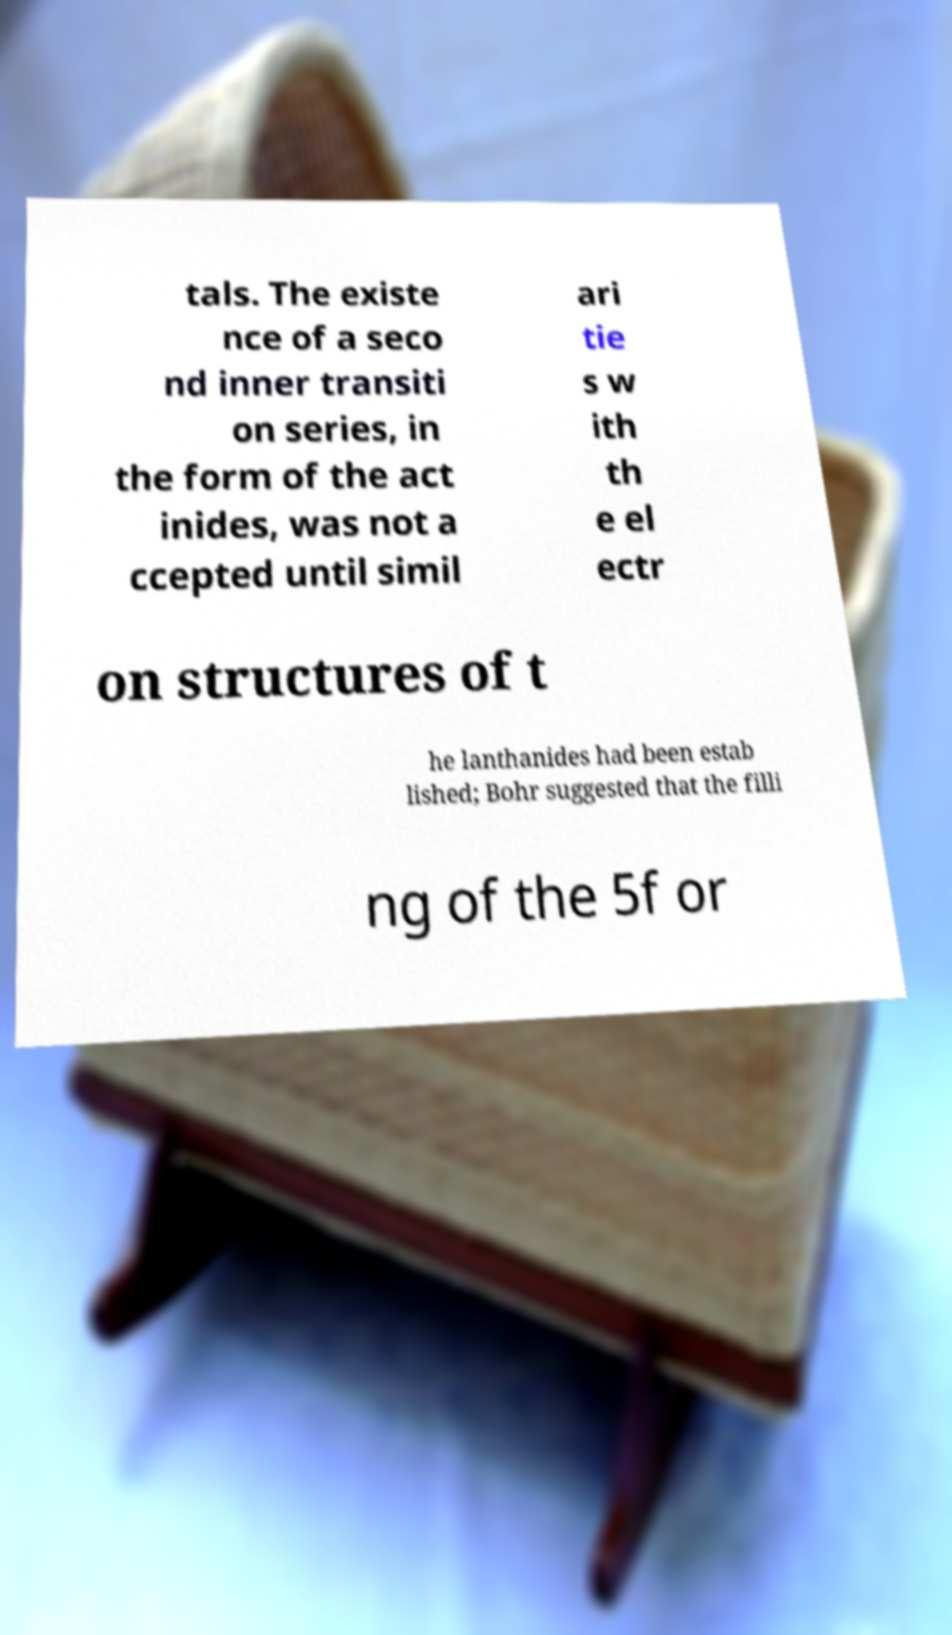What messages or text are displayed in this image? I need them in a readable, typed format. tals. The existe nce of a seco nd inner transiti on series, in the form of the act inides, was not a ccepted until simil ari tie s w ith th e el ectr on structures of t he lanthanides had been estab lished; Bohr suggested that the filli ng of the 5f or 